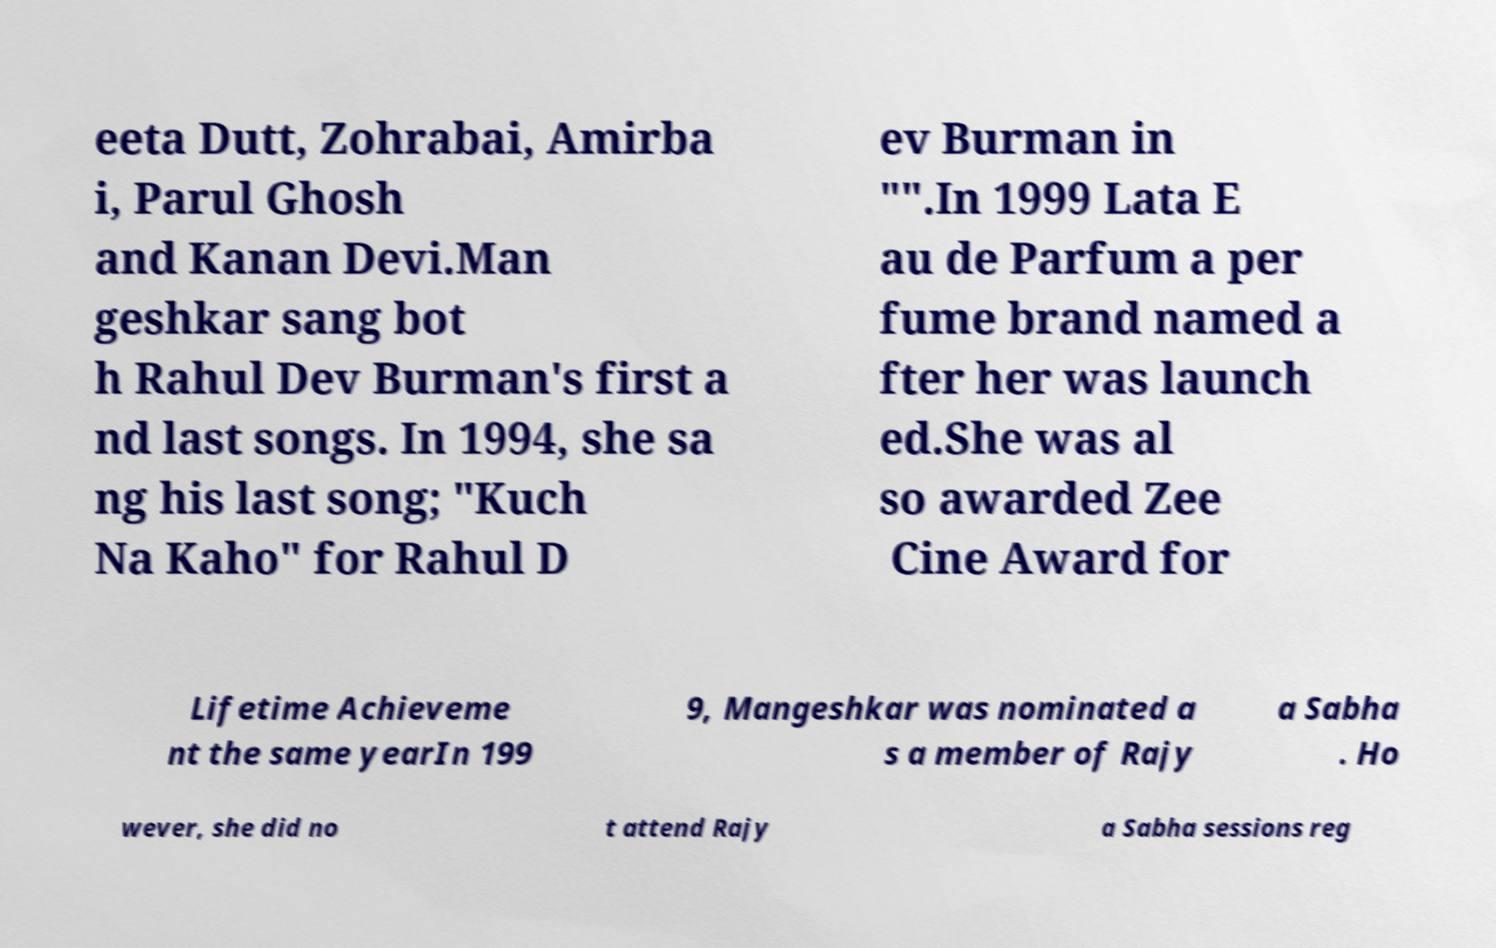What messages or text are displayed in this image? I need them in a readable, typed format. eeta Dutt, Zohrabai, Amirba i, Parul Ghosh and Kanan Devi.Man geshkar sang bot h Rahul Dev Burman's first a nd last songs. In 1994, she sa ng his last song; "Kuch Na Kaho" for Rahul D ev Burman in "".In 1999 Lata E au de Parfum a per fume brand named a fter her was launch ed.She was al so awarded Zee Cine Award for Lifetime Achieveme nt the same yearIn 199 9, Mangeshkar was nominated a s a member of Rajy a Sabha . Ho wever, she did no t attend Rajy a Sabha sessions reg 